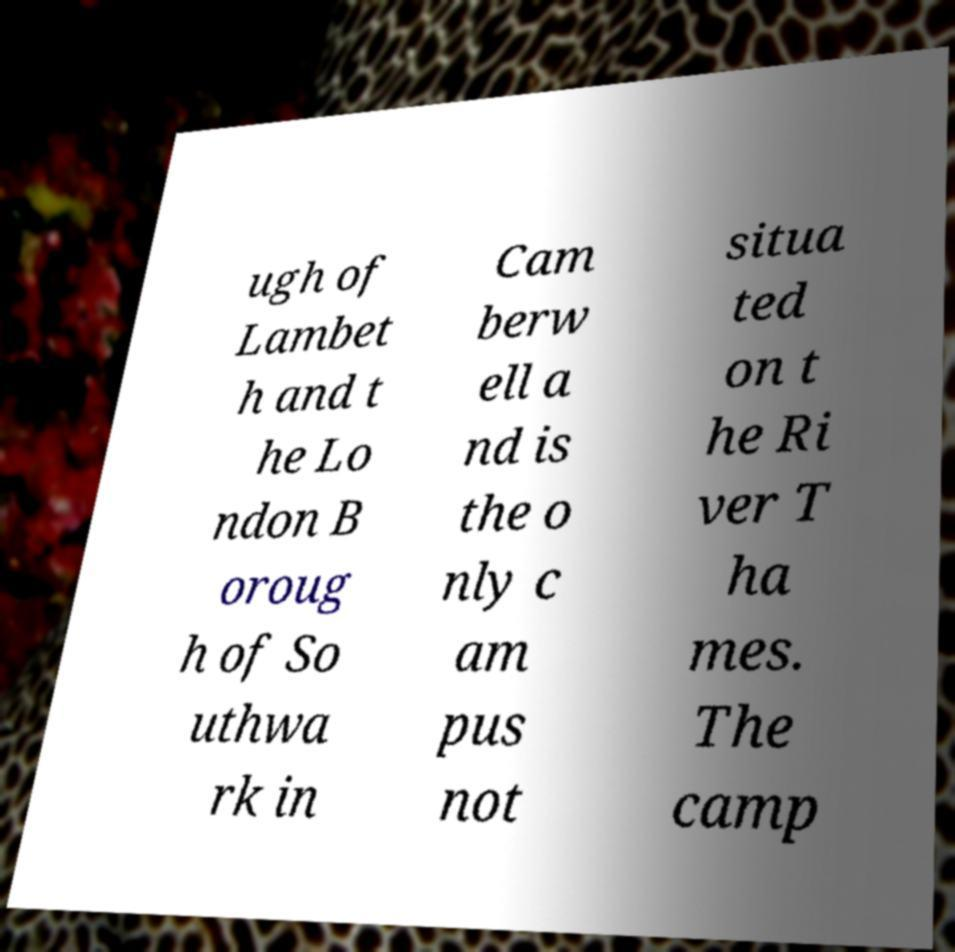Could you assist in decoding the text presented in this image and type it out clearly? ugh of Lambet h and t he Lo ndon B oroug h of So uthwa rk in Cam berw ell a nd is the o nly c am pus not situa ted on t he Ri ver T ha mes. The camp 